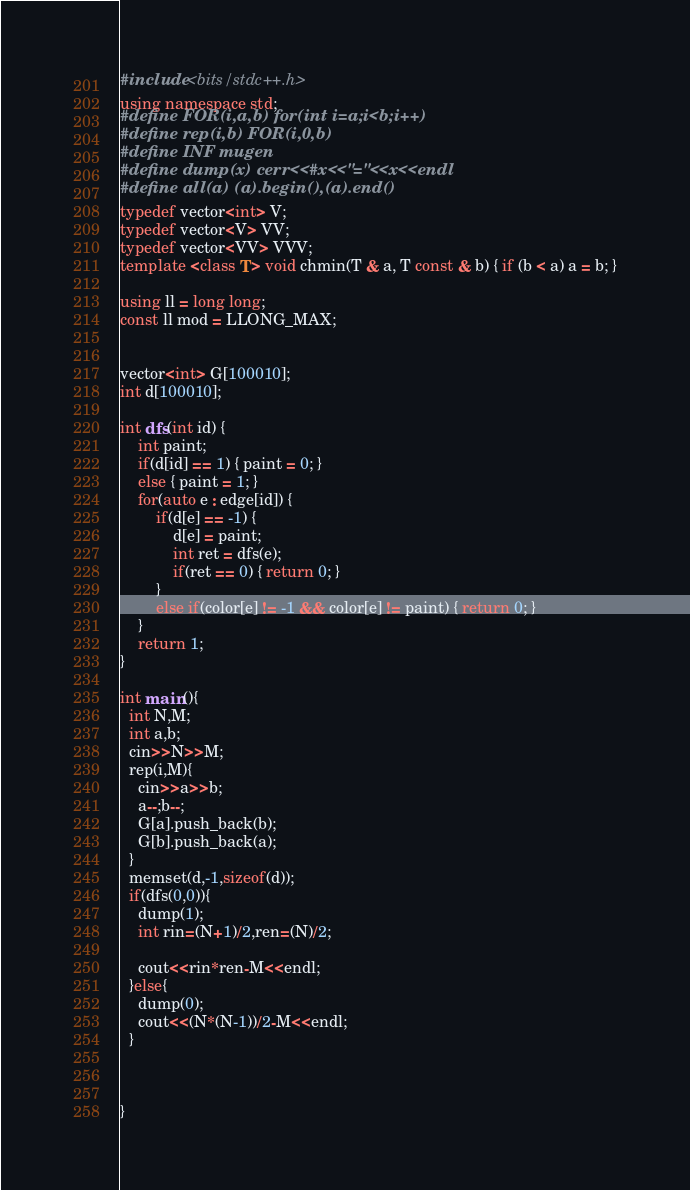<code> <loc_0><loc_0><loc_500><loc_500><_C++_>#include <bits/stdc++.h>
using namespace std;
#define FOR(i,a,b) for(int i=a;i<b;i++)
#define rep(i,b) FOR(i,0,b)
#define INF mugen
#define dump(x) cerr<<#x<<"="<<x<<endl
#define all(a) (a).begin(),(a).end()
typedef vector<int> V;
typedef vector<V> VV;
typedef vector<VV> VVV;
template <class T> void chmin(T & a, T const & b) { if (b < a) a = b; }

using ll = long long;
const ll mod = LLONG_MAX;


vector<int> G[100010];
int d[100010];

int dfs(int id) {
    int paint;
    if(d[id] == 1) { paint = 0; }
    else { paint = 1; }
    for(auto e : edge[id]) {
        if(d[e] == -1) {
            d[e] = paint;
            int ret = dfs(e);
            if(ret == 0) { return 0; }
        }
        else if(color[e] != -1 && color[e] != paint) { return 0; }
    }
    return 1;
}

int main(){
  int N,M;
  int a,b;
  cin>>N>>M;
  rep(i,M){
    cin>>a>>b;
    a--;b--;
    G[a].push_back(b);
    G[b].push_back(a);
  }
  memset(d,-1,sizeof(d));
  if(dfs(0,0)){
    dump(1);
    int rin=(N+1)/2,ren=(N)/2;

    cout<<rin*ren-M<<endl;
  }else{
    dump(0);
    cout<<(N*(N-1))/2-M<<endl;
  }



}
</code> 